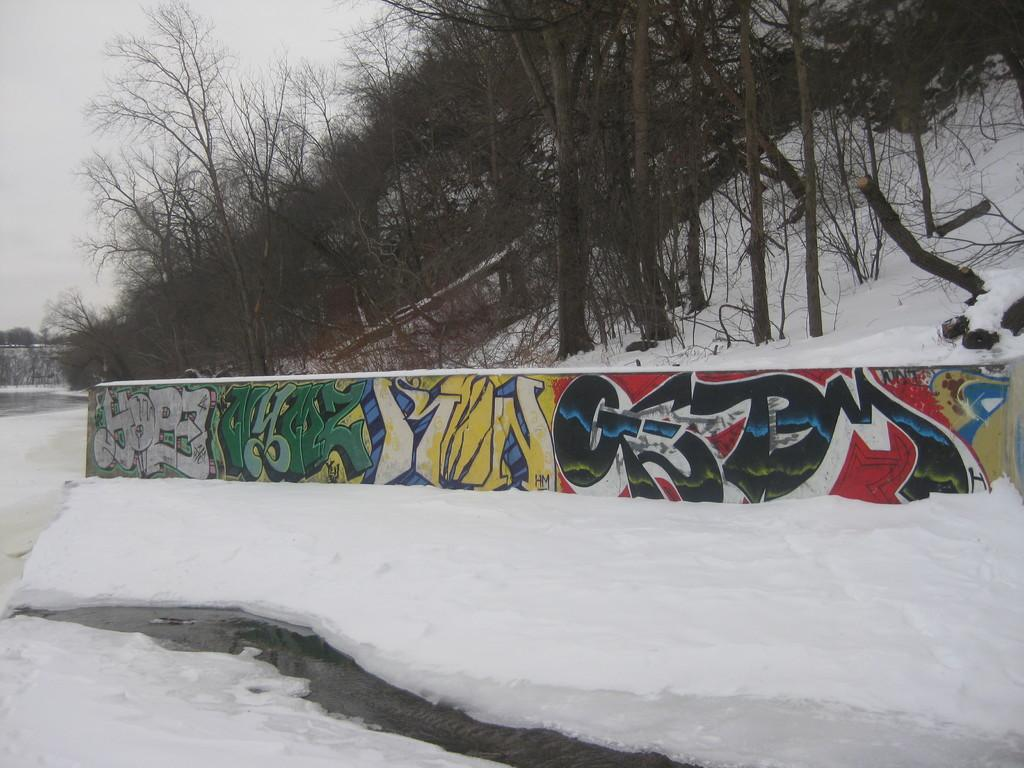What is depicted on the wall in the image? There is a painting on the wall in the image. What type of weather is shown in the image? There is snow visible in the image, indicating a winter scene. What type of vegetation is present in the image? There are trees in the image. What can be seen in the background of the image? The sky is visible in the background of the image. Reasoning: Let' Let's think step by step in order to produce the conversation. We start by identifying the main subjects and objects in the image based on the provided facts. We then formulate questions that focus on the location and characteristics of these subjects and objects, ensuring that each question can be answered definitively with the information given. We avoid yes/no questions and ensure that the language is simple and clear. Absurd Question/Answer: What time of day is it in the image, as indicated by the hour on the clock? There is no clock present in the image, so we cannot determine the time of day based on an hour. What type of root is growing near the trees in the image? There are no roots visible in the image; only trees are present. 